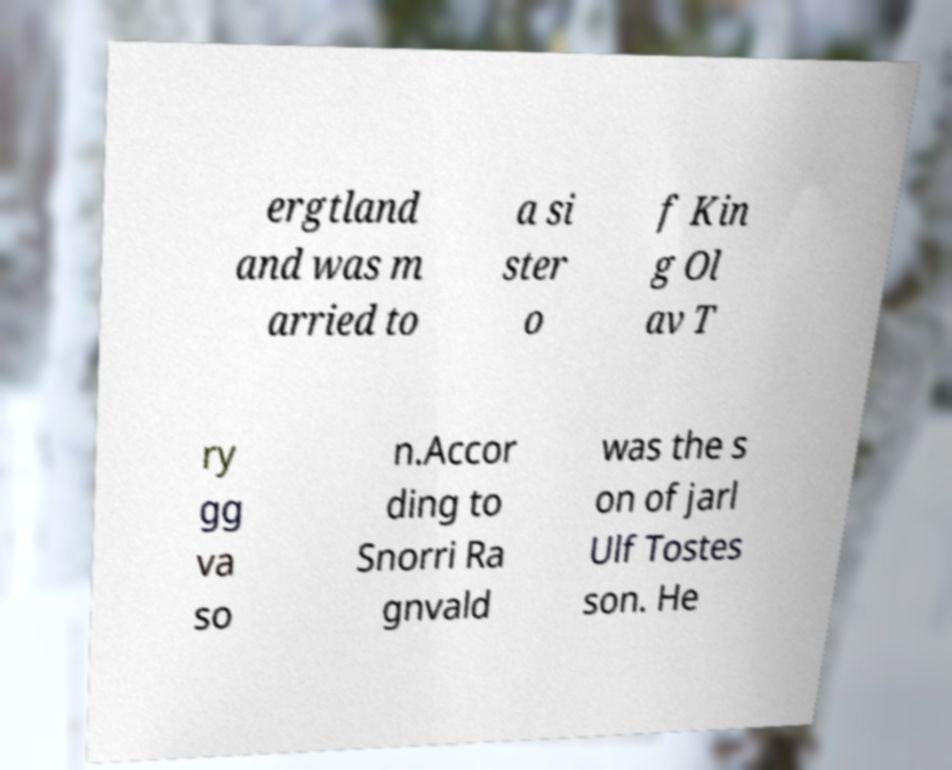There's text embedded in this image that I need extracted. Can you transcribe it verbatim? ergtland and was m arried to a si ster o f Kin g Ol av T ry gg va so n.Accor ding to Snorri Ra gnvald was the s on of jarl Ulf Tostes son. He 